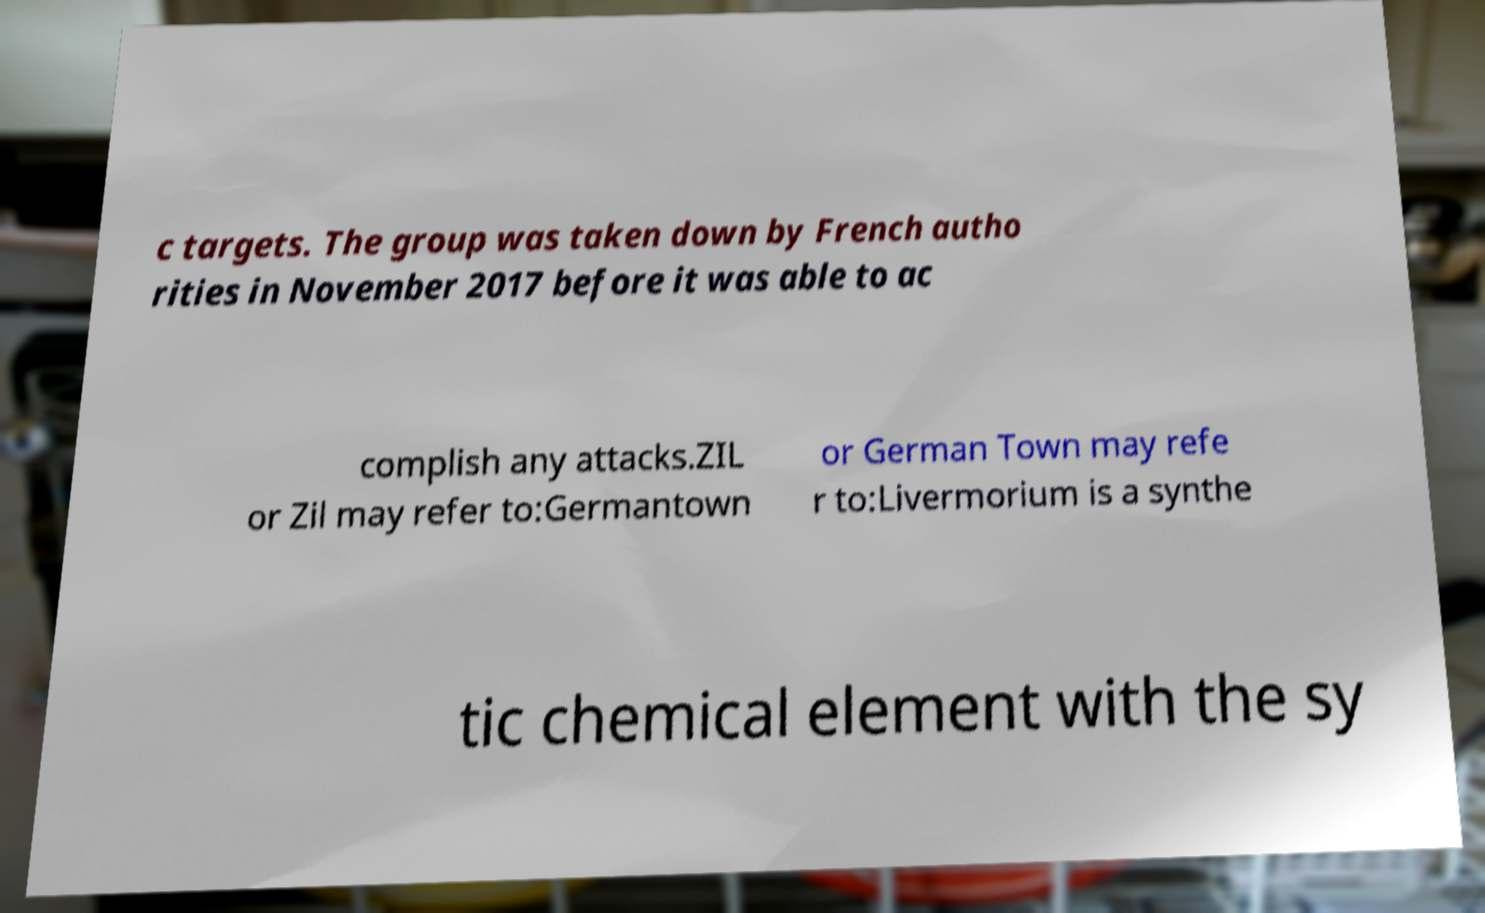For documentation purposes, I need the text within this image transcribed. Could you provide that? c targets. The group was taken down by French autho rities in November 2017 before it was able to ac complish any attacks.ZIL or Zil may refer to:Germantown or German Town may refe r to:Livermorium is a synthe tic chemical element with the sy 